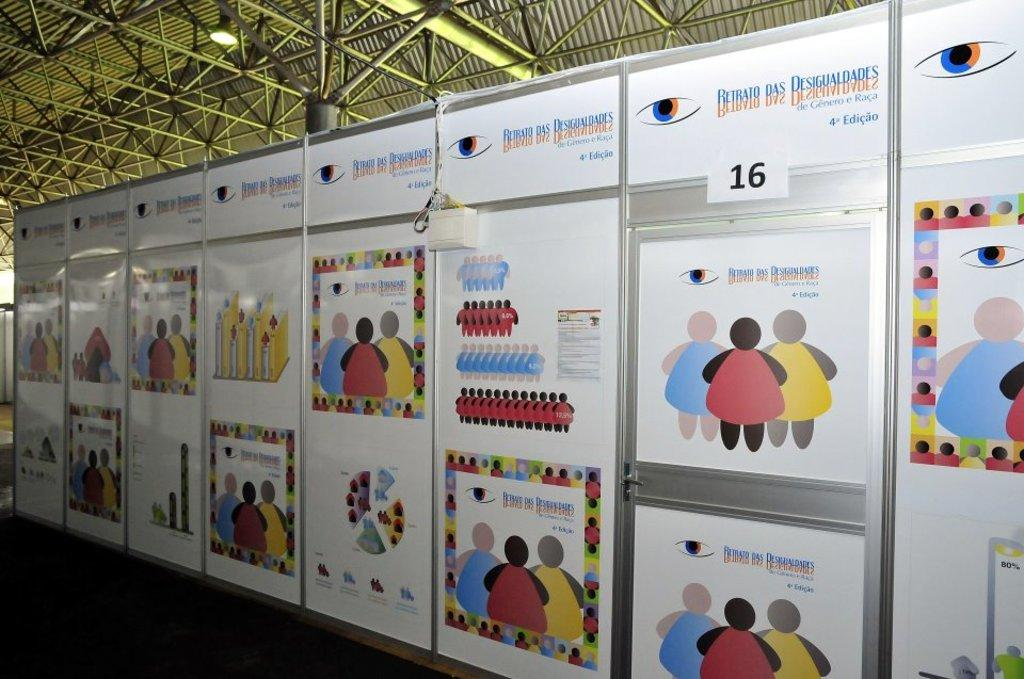<image>
Write a terse but informative summary of the picture. many images of cartoon like people are on a wall with the number 16 